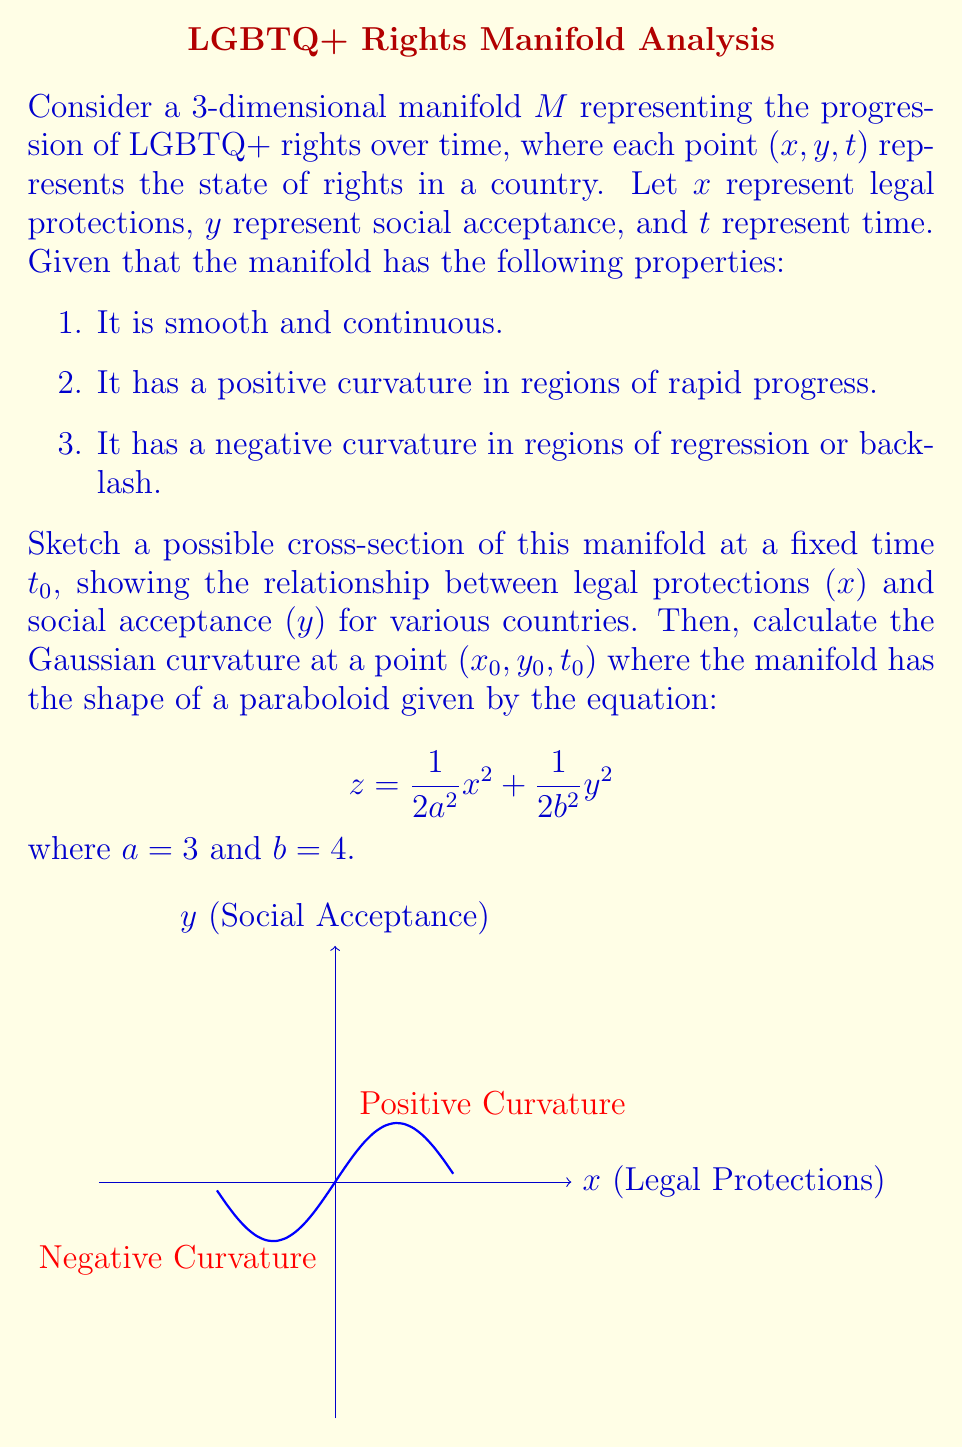Can you answer this question? To approach this problem, we'll follow these steps:

1. Sketch the cross-section:
[asy]
import graph;
size(200,200);
xaxis("Legal protections (x)", Arrow);
yaxis("Social acceptance (y)", Arrow);

path p = (0,0){1,1}..{1,2}(2,3)..{1,0}(4,3.5);
draw(p, blue+1);

label("Country A", (0.5,0.5), SW);
label("Country B", (2,3), N);
label("Country C", (4,3.5), SE);
[/asy]

This sketch shows a possible relationship between legal protections and social acceptance at a fixed time. The curve represents different countries, with some showing a correlation between legal protections and social acceptance, while others may have disparities.

2. To calculate the Gaussian curvature, we need to use the formula for a paraboloid:

$$K = \frac{1}{a^2b^2}$$

Where $K$ is the Gaussian curvature, and $a$ and $b$ are the coefficients in the paraboloid equation.

3. Given $a = 3$ and $b = 4$, we can substitute these values:

$$K = \frac{1}{3^2 \cdot 4^2} = \frac{1}{144}$$

4. Simplify:

$$K = \frac{1}{144} \approx 0.00694444$$

This positive curvature indicates that at the point $(x_0, y_0, t_0)$, the manifold is locally convex, suggesting a region of progress in LGBTQ+ rights.
Answer: $K = \frac{1}{144}$ 